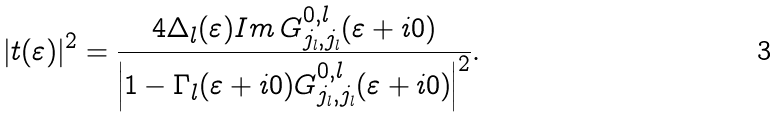<formula> <loc_0><loc_0><loc_500><loc_500>| t ( \varepsilon ) | ^ { 2 } = \frac { 4 \Delta _ { l } ( \varepsilon ) I m \, G _ { j _ { l } , j _ { l } } ^ { 0 , l } ( \varepsilon + i 0 ) } { \left | 1 - \Gamma _ { l } ( \varepsilon + i 0 ) G _ { j _ { l } , j _ { l } } ^ { 0 , l } ( \varepsilon + i 0 ) \right | ^ { 2 } } .</formula> 